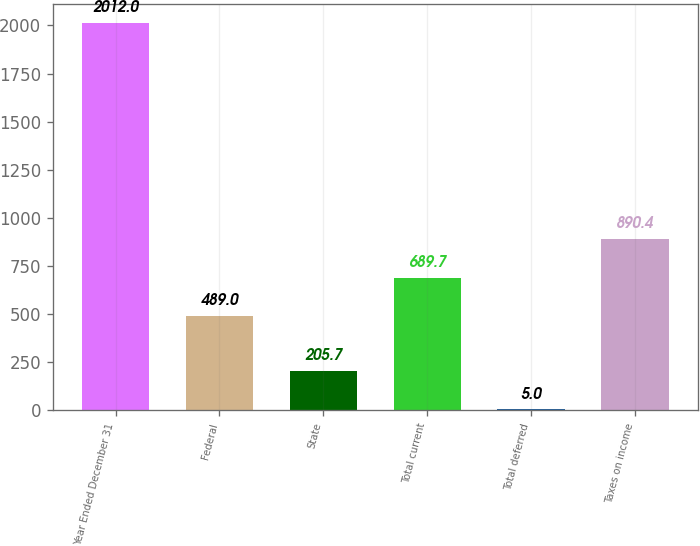Convert chart. <chart><loc_0><loc_0><loc_500><loc_500><bar_chart><fcel>Year Ended December 31<fcel>Federal<fcel>State<fcel>Total current<fcel>Total deferred<fcel>Taxes on income<nl><fcel>2012<fcel>489<fcel>205.7<fcel>689.7<fcel>5<fcel>890.4<nl></chart> 